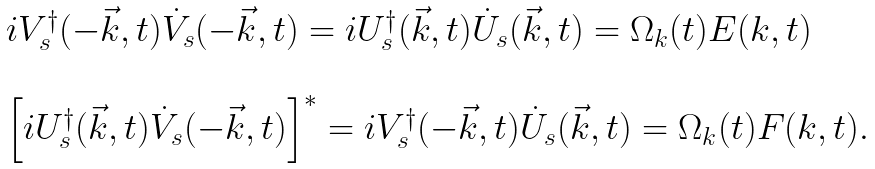<formula> <loc_0><loc_0><loc_500><loc_500>\begin{array} { l } i V _ { s } ^ { \dagger } ( - \vec { k } , t ) \dot { V } _ { s } ( - \vec { k } , t ) = i U _ { s } ^ { \dagger } ( \vec { k } , t ) \dot { U } _ { s } ( \vec { k } , t ) = \Omega _ { k } ( t ) E ( k , t ) \\ \\ \left [ i U _ { s } ^ { \dagger } ( \vec { k } , t ) \dot { V } _ { s } ( - \vec { k } , t ) \right ] ^ { * } = i V _ { s } ^ { \dagger } ( - \vec { k } , t ) \dot { U } _ { s } ( \vec { k } , t ) = \Omega _ { k } ( t ) F ( k , t ) . \end{array}</formula> 